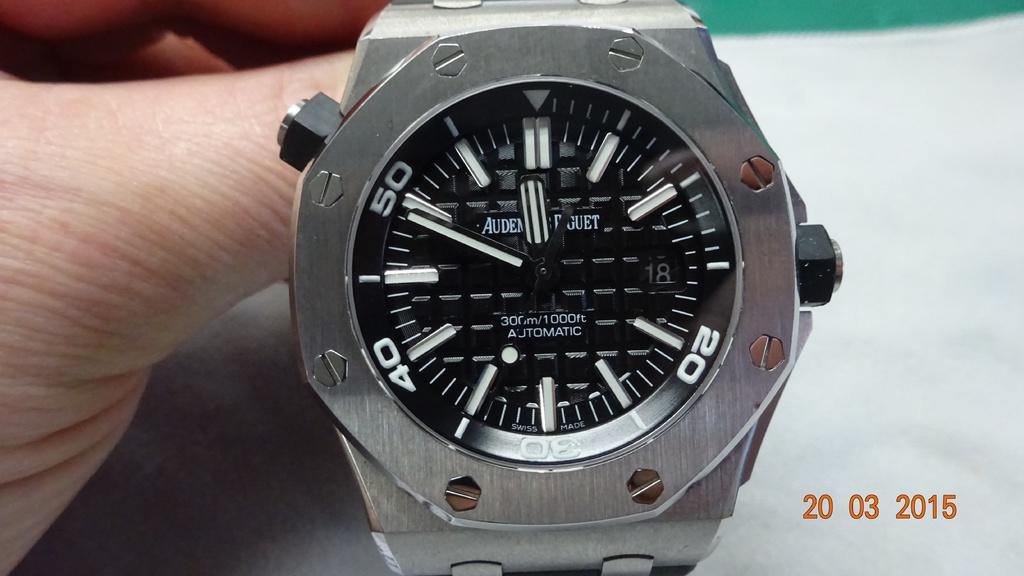<image>
Create a compact narrative representing the image presented. A photograph of a watch was taken in 20 03 2015. 